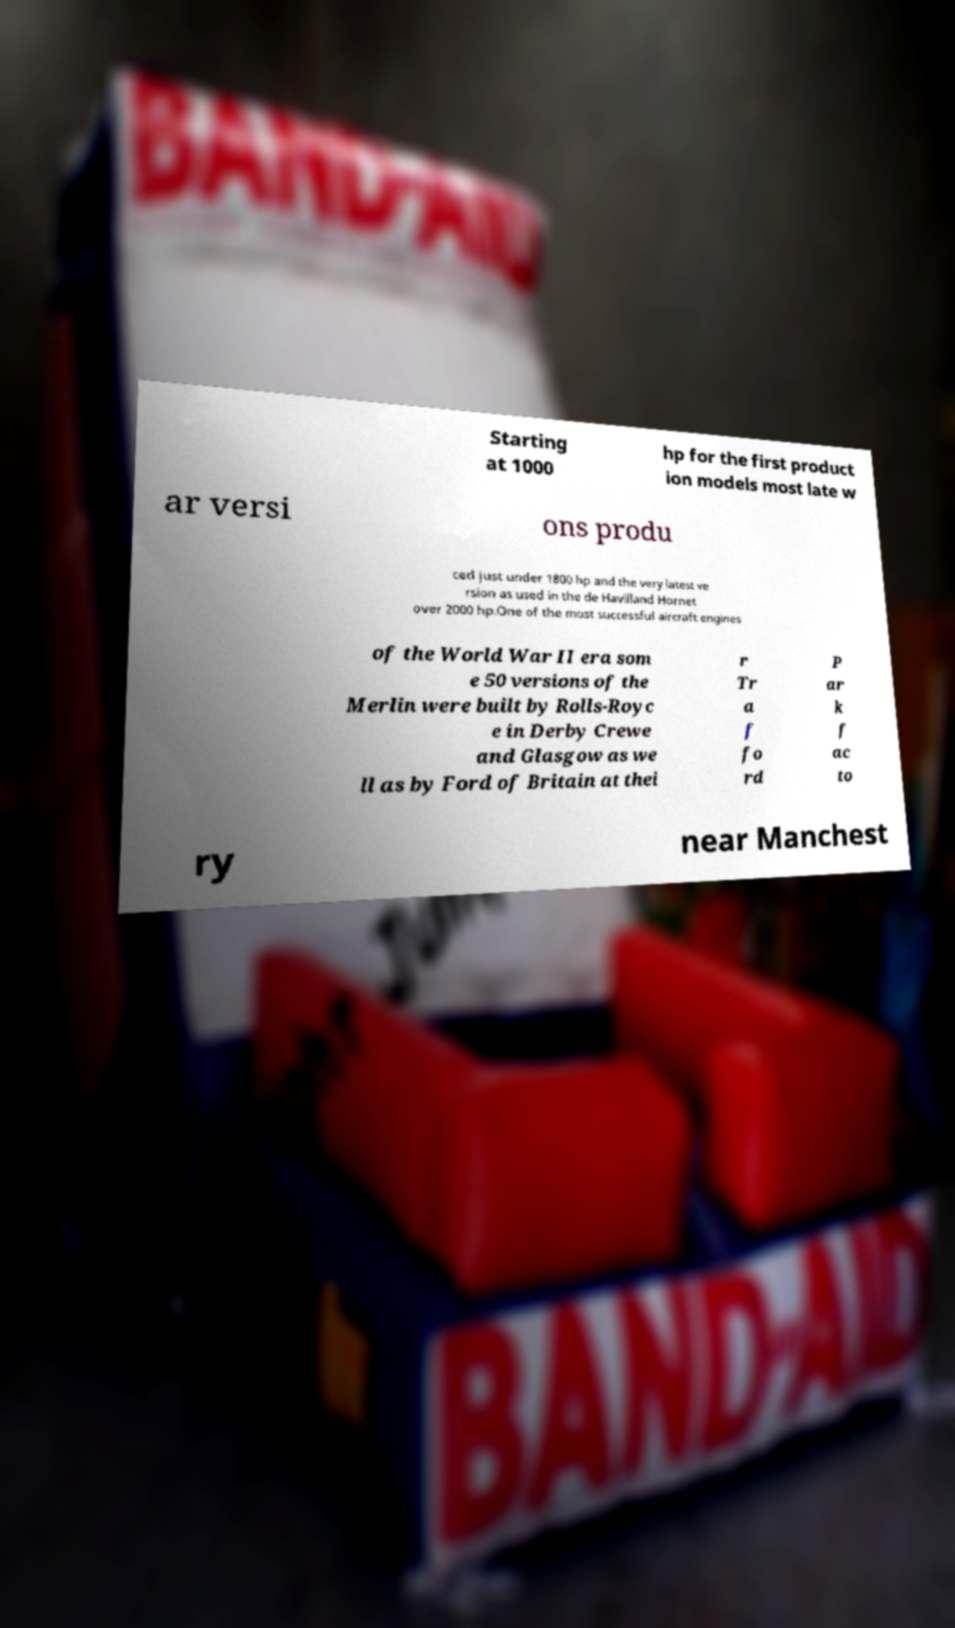Can you accurately transcribe the text from the provided image for me? Starting at 1000 hp for the first product ion models most late w ar versi ons produ ced just under 1800 hp and the very latest ve rsion as used in the de Havilland Hornet over 2000 hp.One of the most successful aircraft engines of the World War II era som e 50 versions of the Merlin were built by Rolls-Royc e in Derby Crewe and Glasgow as we ll as by Ford of Britain at thei r Tr a f fo rd P ar k f ac to ry near Manchest 